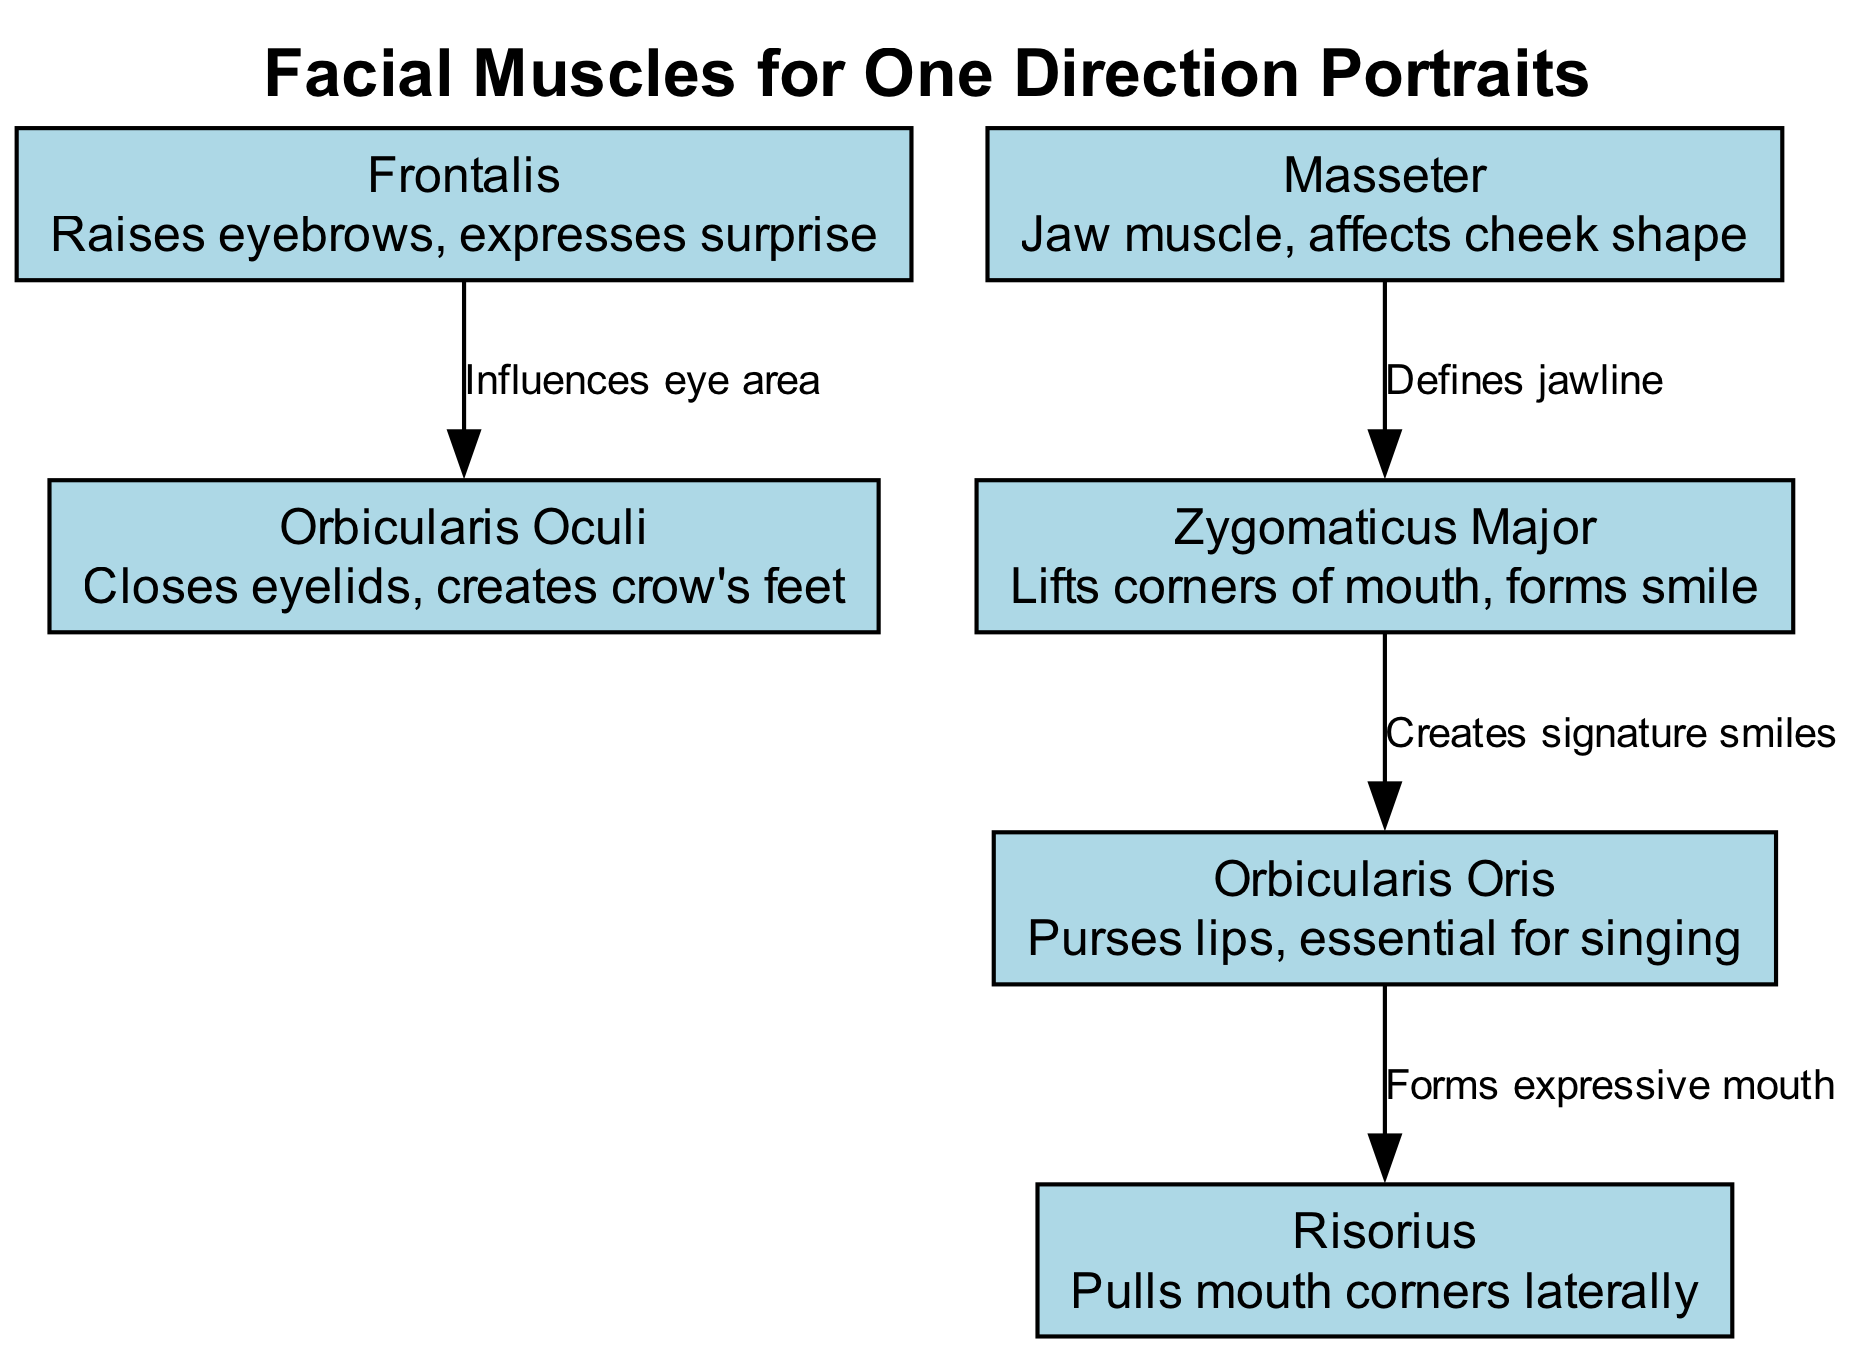What is the total number of facial muscles depicted? The diagram lists six unique muscles, each represented by a node. By counting these nodes in the diagram, we find that there are six muscles in total.
Answer: 6 Which muscle is responsible for raising eyebrows? The Frontalis muscle is explicitly described as the one that raises eyebrows and expresses surprise, making it the correct answer.
Answer: Frontalis How many edges are present in the diagram? By examining the connections drawn between the nodes, a total of four edges is present. Each connection represents a relationship or influence between two muscles.
Answer: 4 Which muscle creates the signature smiles according to the diagram? The Zygomaticus Major muscle is indicated in the diagram as responsible for lifting the corners of the mouth, which is specifically stated to create signature smiles.
Answer: Zygomaticus Major What relationship influences the eye area in the diagram? The edge between the Frontalis muscle and the Orbicularis Oculi muscle is labeled as influencing the eye area, indicating a functional relationship between these two muscles.
Answer: Influences eye area Which muscle pulls the mouth corners laterally? The Risorius muscle is labeled in the diagram as responsible for pulling the mouth corners laterally, making it the answer to this question.
Answer: Risorius How does the Masseter muscle influence the facial shape? The Masseter muscle defines the jawline, which is indicated in the diagram through its connection to the Zygomaticus Major, suggesting it impacts the overall facial shape.
Answer: Defines jawline Which muscle is essential for singing? The Orbicularis Oris muscle is noted in the diagram as essential for pursing lips, which is important for singing, thus making it the answer.
Answer: Orbicularis Oris 